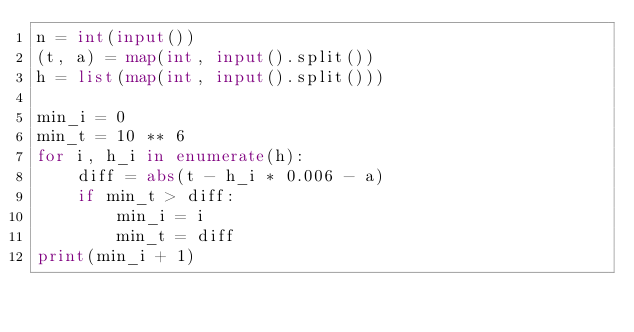<code> <loc_0><loc_0><loc_500><loc_500><_Python_>n = int(input())
(t, a) = map(int, input().split())
h = list(map(int, input().split()))

min_i = 0
min_t = 10 ** 6
for i, h_i in enumerate(h):
    diff = abs(t - h_i * 0.006 - a)
    if min_t > diff:
        min_i = i
        min_t = diff
print(min_i + 1)</code> 